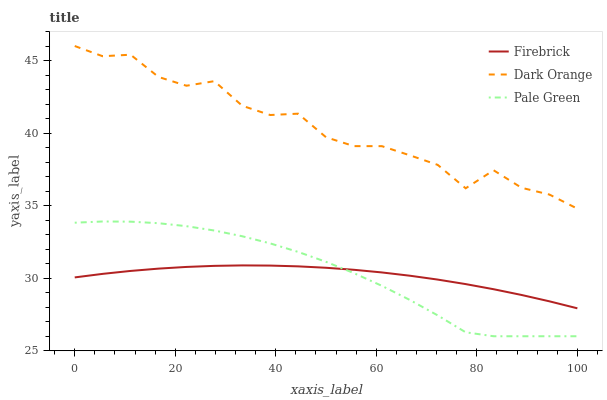Does Firebrick have the minimum area under the curve?
Answer yes or no. Yes. Does Dark Orange have the maximum area under the curve?
Answer yes or no. Yes. Does Pale Green have the minimum area under the curve?
Answer yes or no. No. Does Pale Green have the maximum area under the curve?
Answer yes or no. No. Is Firebrick the smoothest?
Answer yes or no. Yes. Is Dark Orange the roughest?
Answer yes or no. Yes. Is Pale Green the smoothest?
Answer yes or no. No. Is Pale Green the roughest?
Answer yes or no. No. Does Firebrick have the lowest value?
Answer yes or no. No. Does Pale Green have the highest value?
Answer yes or no. No. Is Pale Green less than Dark Orange?
Answer yes or no. Yes. Is Dark Orange greater than Firebrick?
Answer yes or no. Yes. Does Pale Green intersect Dark Orange?
Answer yes or no. No. 